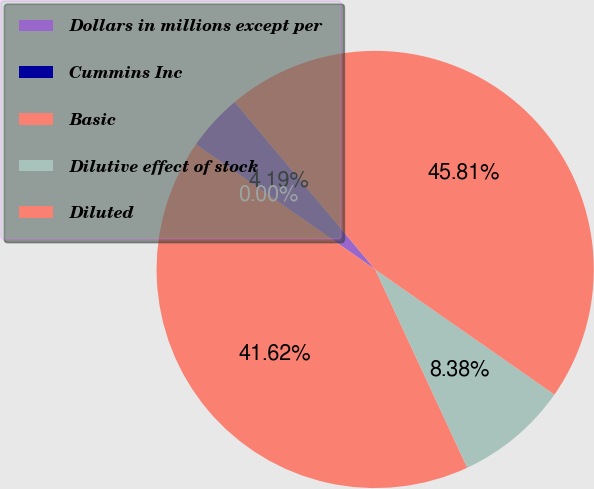<chart> <loc_0><loc_0><loc_500><loc_500><pie_chart><fcel>Dollars in millions except per<fcel>Cummins Inc<fcel>Basic<fcel>Dilutive effect of stock<fcel>Diluted<nl><fcel>4.19%<fcel>0.0%<fcel>41.62%<fcel>8.38%<fcel>45.81%<nl></chart> 